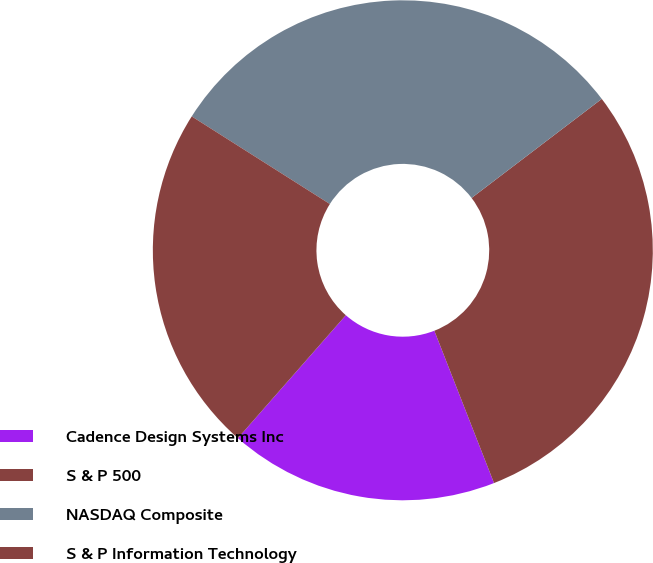<chart> <loc_0><loc_0><loc_500><loc_500><pie_chart><fcel>Cadence Design Systems Inc<fcel>S & P 500<fcel>NASDAQ Composite<fcel>S & P Information Technology<nl><fcel>17.41%<fcel>29.41%<fcel>30.65%<fcel>22.53%<nl></chart> 